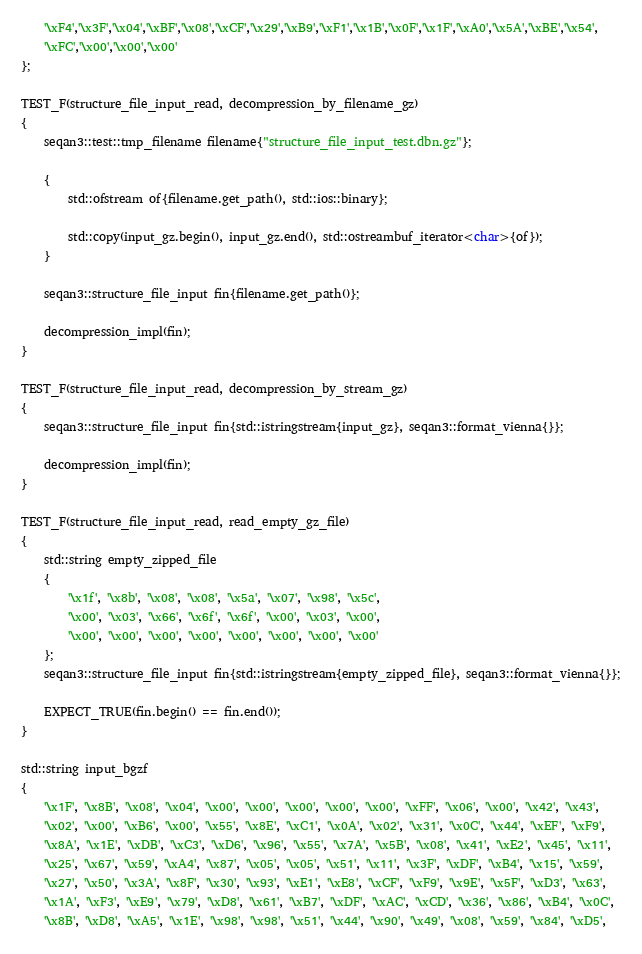<code> <loc_0><loc_0><loc_500><loc_500><_C++_>    '\xF4','\x3F','\x04','\xBF','\x08','\xCF','\x29','\xB9','\xF1','\x1B','\x0F','\x1F','\xA0','\x5A','\xBE','\x54',
    '\xFC','\x00','\x00','\x00'
};

TEST_F(structure_file_input_read, decompression_by_filename_gz)
{
    seqan3::test::tmp_filename filename{"structure_file_input_test.dbn.gz"};

    {
        std::ofstream of{filename.get_path(), std::ios::binary};

        std::copy(input_gz.begin(), input_gz.end(), std::ostreambuf_iterator<char>{of});
    }

    seqan3::structure_file_input fin{filename.get_path()};

    decompression_impl(fin);
}

TEST_F(structure_file_input_read, decompression_by_stream_gz)
{
    seqan3::structure_file_input fin{std::istringstream{input_gz}, seqan3::format_vienna{}};

    decompression_impl(fin);
}

TEST_F(structure_file_input_read, read_empty_gz_file)
{
    std::string empty_zipped_file
    {
        '\x1f', '\x8b', '\x08', '\x08', '\x5a', '\x07', '\x98', '\x5c',
        '\x00', '\x03', '\x66', '\x6f', '\x6f', '\x00', '\x03', '\x00',
        '\x00', '\x00', '\x00', '\x00', '\x00', '\x00', '\x00', '\x00'
    };
    seqan3::structure_file_input fin{std::istringstream{empty_zipped_file}, seqan3::format_vienna{}};

    EXPECT_TRUE(fin.begin() == fin.end());
}

std::string input_bgzf
{
    '\x1F', '\x8B', '\x08', '\x04', '\x00', '\x00', '\x00', '\x00', '\x00', '\xFF', '\x06', '\x00', '\x42', '\x43',
    '\x02', '\x00', '\xB6', '\x00', '\x55', '\x8E', '\xC1', '\x0A', '\x02', '\x31', '\x0C', '\x44', '\xEF', '\xF9',
    '\x8A', '\x1E', '\xDB', '\xC3', '\xD6', '\x96', '\x55', '\x7A', '\x5B', '\x08', '\x41', '\xE2', '\x45', '\x11',
    '\x25', '\x67', '\x59', '\xA4', '\x87', '\x05', '\x05', '\x51', '\x11', '\x3F', '\xDF', '\xB4', '\x15', '\x59',
    '\x27', '\x50', '\x3A', '\x8F', '\x30', '\x93', '\xE1', '\xE8', '\xCF', '\xF9', '\x9E', '\x5F', '\xD3', '\x63',
    '\x1A', '\xF3', '\xE9', '\x79', '\xD8', '\x61', '\xB7', '\xDF', '\xAC', '\xCD', '\x36', '\x86', '\xB4', '\x0C',
    '\x8B', '\xD8', '\xA5', '\x1E', '\x98', '\x98', '\x51', '\x44', '\x90', '\x49', '\x08', '\x59', '\x84', '\xD5',</code> 